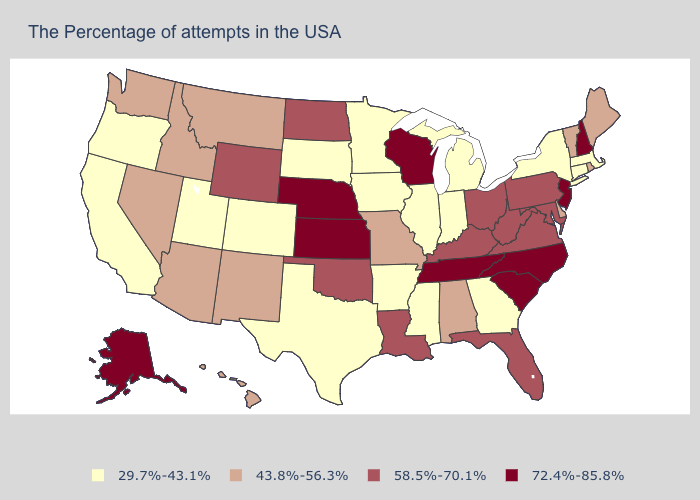Name the states that have a value in the range 29.7%-43.1%?
Give a very brief answer. Massachusetts, Connecticut, New York, Georgia, Michigan, Indiana, Illinois, Mississippi, Arkansas, Minnesota, Iowa, Texas, South Dakota, Colorado, Utah, California, Oregon. What is the value of Washington?
Be succinct. 43.8%-56.3%. What is the value of Montana?
Keep it brief. 43.8%-56.3%. What is the value of Pennsylvania?
Write a very short answer. 58.5%-70.1%. What is the lowest value in states that border Utah?
Give a very brief answer. 29.7%-43.1%. What is the lowest value in the USA?
Keep it brief. 29.7%-43.1%. Does Rhode Island have the highest value in the USA?
Give a very brief answer. No. Does the first symbol in the legend represent the smallest category?
Be succinct. Yes. Does New Hampshire have the highest value in the Northeast?
Give a very brief answer. Yes. Does New Hampshire have the lowest value in the Northeast?
Quick response, please. No. Name the states that have a value in the range 72.4%-85.8%?
Write a very short answer. New Hampshire, New Jersey, North Carolina, South Carolina, Tennessee, Wisconsin, Kansas, Nebraska, Alaska. What is the highest value in states that border New Jersey?
Keep it brief. 58.5%-70.1%. Does Utah have the highest value in the USA?
Short answer required. No. Which states have the highest value in the USA?
Short answer required. New Hampshire, New Jersey, North Carolina, South Carolina, Tennessee, Wisconsin, Kansas, Nebraska, Alaska. 